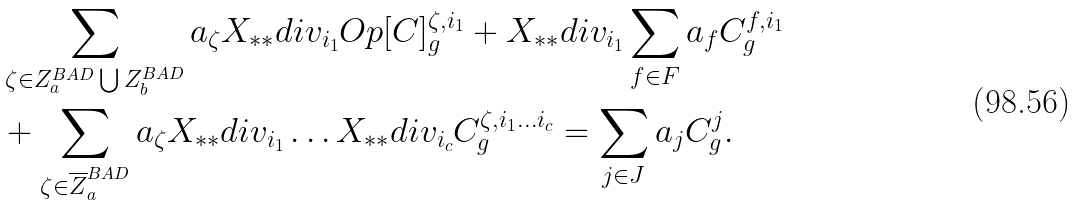Convert formula to latex. <formula><loc_0><loc_0><loc_500><loc_500>& \sum _ { \zeta \in Z _ { a } ^ { B A D } \bigcup Z _ { b } ^ { B A D } } a _ { \zeta } X _ { * * } d i v _ { i _ { 1 } } O p [ C ] ^ { \zeta , i _ { 1 } } _ { g } + X _ { * * } d i v _ { i _ { 1 } } \sum _ { f \in F } a _ { f } C ^ { f , i _ { 1 } } _ { g } \\ & + \sum _ { \zeta \in \overline { Z } _ { a } ^ { B A D } } a _ { \zeta } X _ { * * } d i v _ { i _ { 1 } } \dots X _ { * * } d i v _ { i _ { c } } C ^ { \zeta , i _ { 1 } \dots i _ { c } } _ { g } = \sum _ { j \in J } a _ { j } C ^ { j } _ { g } .</formula> 